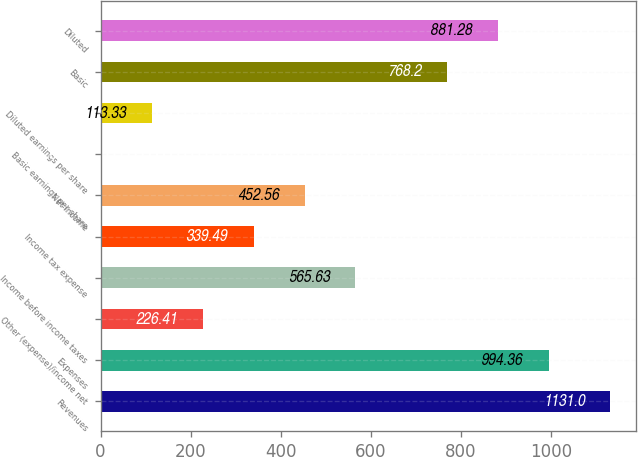Convert chart to OTSL. <chart><loc_0><loc_0><loc_500><loc_500><bar_chart><fcel>Revenues<fcel>Expenses<fcel>Other (expense)/income net<fcel>Income before income taxes<fcel>Income tax expense<fcel>Net income<fcel>Basic earnings per share<fcel>Diluted earnings per share<fcel>Basic<fcel>Diluted<nl><fcel>1131<fcel>994.36<fcel>226.41<fcel>565.63<fcel>339.49<fcel>452.56<fcel>0.25<fcel>113.33<fcel>768.2<fcel>881.28<nl></chart> 